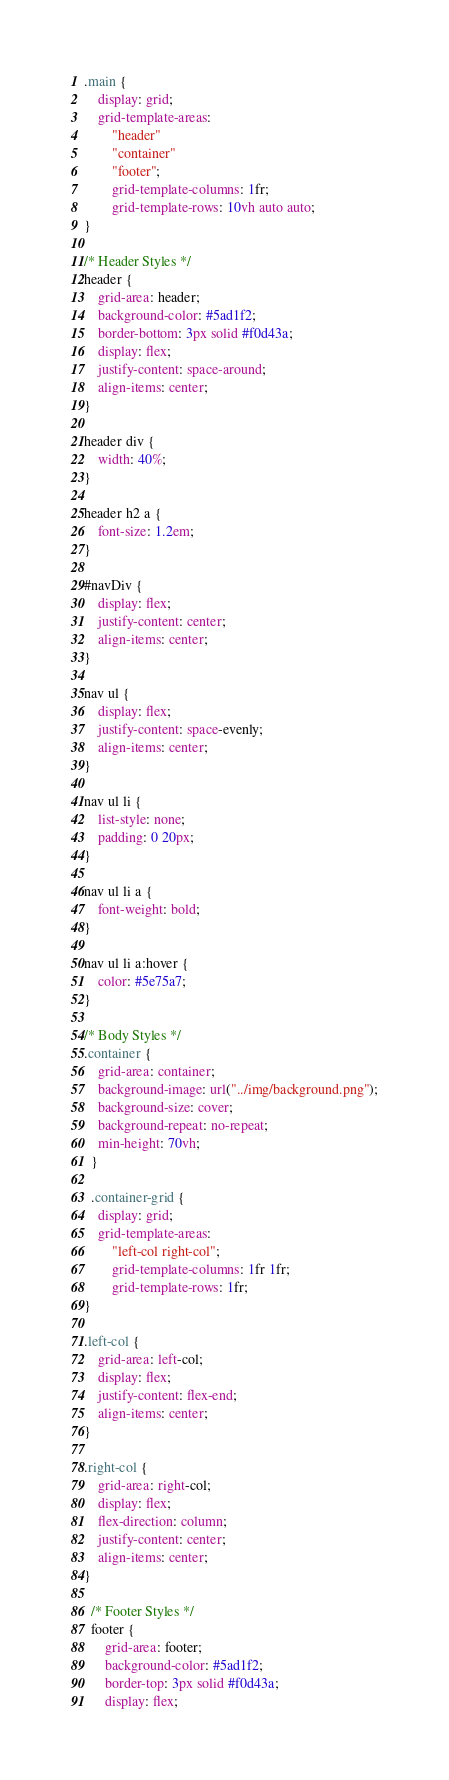<code> <loc_0><loc_0><loc_500><loc_500><_CSS_>.main {
    display: grid;
    grid-template-areas: 
        "header"
        "container"
        "footer";
        grid-template-columns: 1fr;
        grid-template-rows: 10vh auto auto;
}

/* Header Styles */
header {
    grid-area: header;
    background-color: #5ad1f2;
    border-bottom: 3px solid #f0d43a;
    display: flex;
    justify-content: space-around;
    align-items: center;
}

header div {
    width: 40%;
}

header h2 a {
    font-size: 1.2em;
}

#navDiv {
    display: flex;
    justify-content: center;
    align-items: center;
}

nav ul {
    display: flex;
    justify-content: space-evenly;
    align-items: center;
}

nav ul li {
    list-style: none;
    padding: 0 20px;
}

nav ul li a {
    font-weight: bold;
}

nav ul li a:hover {
    color: #5e75a7;
}

/* Body Styles */
.container {
    grid-area: container;
    background-image: url("../img/background.png");
    background-size: cover;
    background-repeat: no-repeat;
    min-height: 70vh;
  }

  .container-grid {
    display: grid;
    grid-template-areas: 
        "left-col right-col";
        grid-template-columns: 1fr 1fr;
        grid-template-rows: 1fr;
}

.left-col {
    grid-area: left-col;
    display: flex;
    justify-content: flex-end;
    align-items: center;
}

.right-col {
    grid-area: right-col;
    display: flex;
    flex-direction: column;
    justify-content: center;
    align-items: center;
}

  /* Footer Styles */
  footer {
      grid-area: footer;
      background-color: #5ad1f2;
      border-top: 3px solid #f0d43a;
      display: flex;</code> 